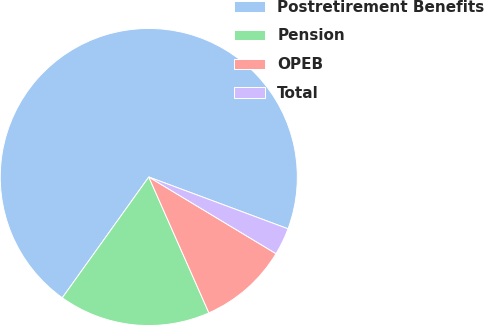<chart> <loc_0><loc_0><loc_500><loc_500><pie_chart><fcel>Postretirement Benefits<fcel>Pension<fcel>OPEB<fcel>Total<nl><fcel>70.78%<fcel>16.52%<fcel>9.74%<fcel>2.96%<nl></chart> 